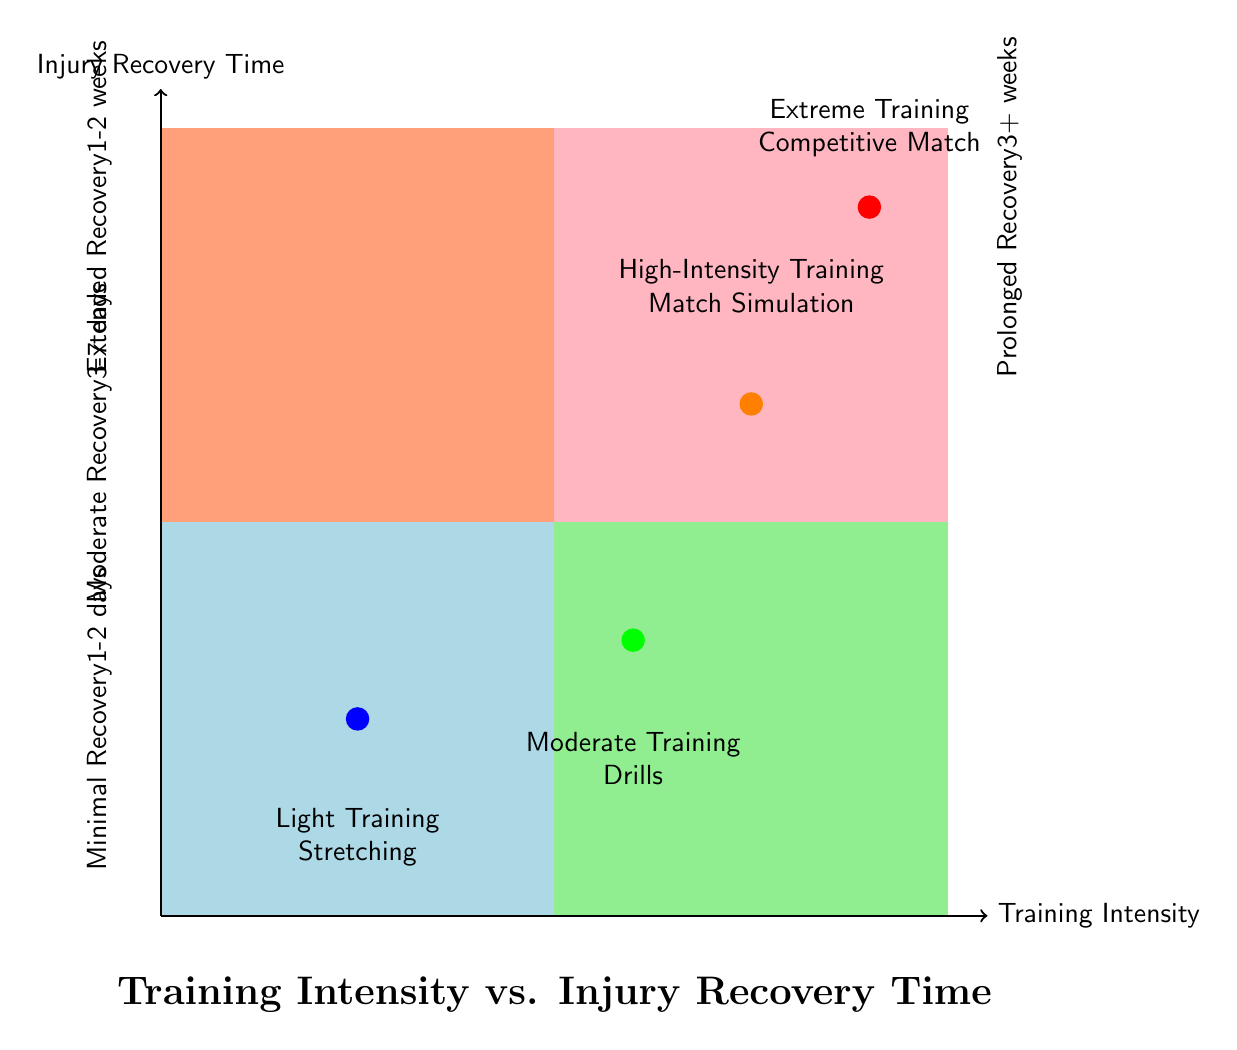What training intensity is associated with minimal recovery time? The diagram shows that "Light Training - Stretching" corresponds to the quadrant with "Minimal Recovery - 1-2 days," indicating that this training intensity results in the shortest recovery time.
Answer: Light Training - Stretching How many training intensities result in prolonged recovery? By examining the diagram, we see that "Extreme Training - Competitive Match" is the only training intensity associated with "Prolonged Recovery - 3+ weeks," making it one.
Answer: 1 What recovery time follows high-intensity training? The data indicates that "High-Intensity Training - Match Simulation" leads to "Extended Recovery - 1-2 weeks," providing information about the recovery duration after this training intensity.
Answer: Extended Recovery - 1-2 weeks Which intensity has the longest injury recovery time? The highest level on the recovery axis is "Prolonged Recovery - 3+ weeks," which corresponds to "Extreme Training - Competitive Match," making it the training intensity with the longest recovery time.
Answer: Extreme Training - Competitive Match What is the relationship between moderate training and recovery time? "Moderate Training - Drills" is linked with "Moderate Recovery - 3-7 days" in the diagram, indicating a direct correlation between this level of training intensity and the associated recovery time.
Answer: Moderate Recovery - 3-7 days How are light training and injury recovery categorized in the diagram? The quadrant representing light training is colored light blue, which corresponds to "Minimal Recovery - 1-2 days," demonstrating a low risk of injury and a short recovery period.
Answer: Light blue, Minimal Recovery - 1-2 days Which training intensity leads to an extended recovery period? The diagram specifies that "High-Intensity Training - Match Simulation" corresponds to "Extended Recovery - 1-2 weeks," showing that this intensity results in a longer recovery time than moderate training.
Answer: High-Intensity Training - Match Simulation What color represents prolonged recovery on the diagram? The area linked to "Prolonged Recovery - 3+ weeks" is filled with light pink, allowing us to easily identify this category visually.
Answer: Light pink 